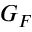Convert formula to latex. <formula><loc_0><loc_0><loc_500><loc_500>G _ { F }</formula> 